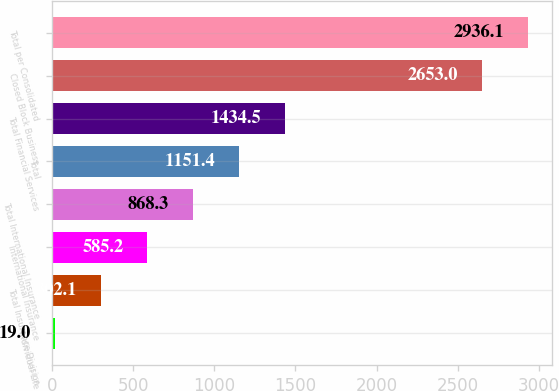Convert chart. <chart><loc_0><loc_0><loc_500><loc_500><bar_chart><fcel>Individual Life<fcel>Total Insurance Division<fcel>International Insurance<fcel>Total International Insurance<fcel>Total<fcel>Total Financial Services<fcel>Closed Block Business<fcel>Total per Consolidated<nl><fcel>19<fcel>302.1<fcel>585.2<fcel>868.3<fcel>1151.4<fcel>1434.5<fcel>2653<fcel>2936.1<nl></chart> 